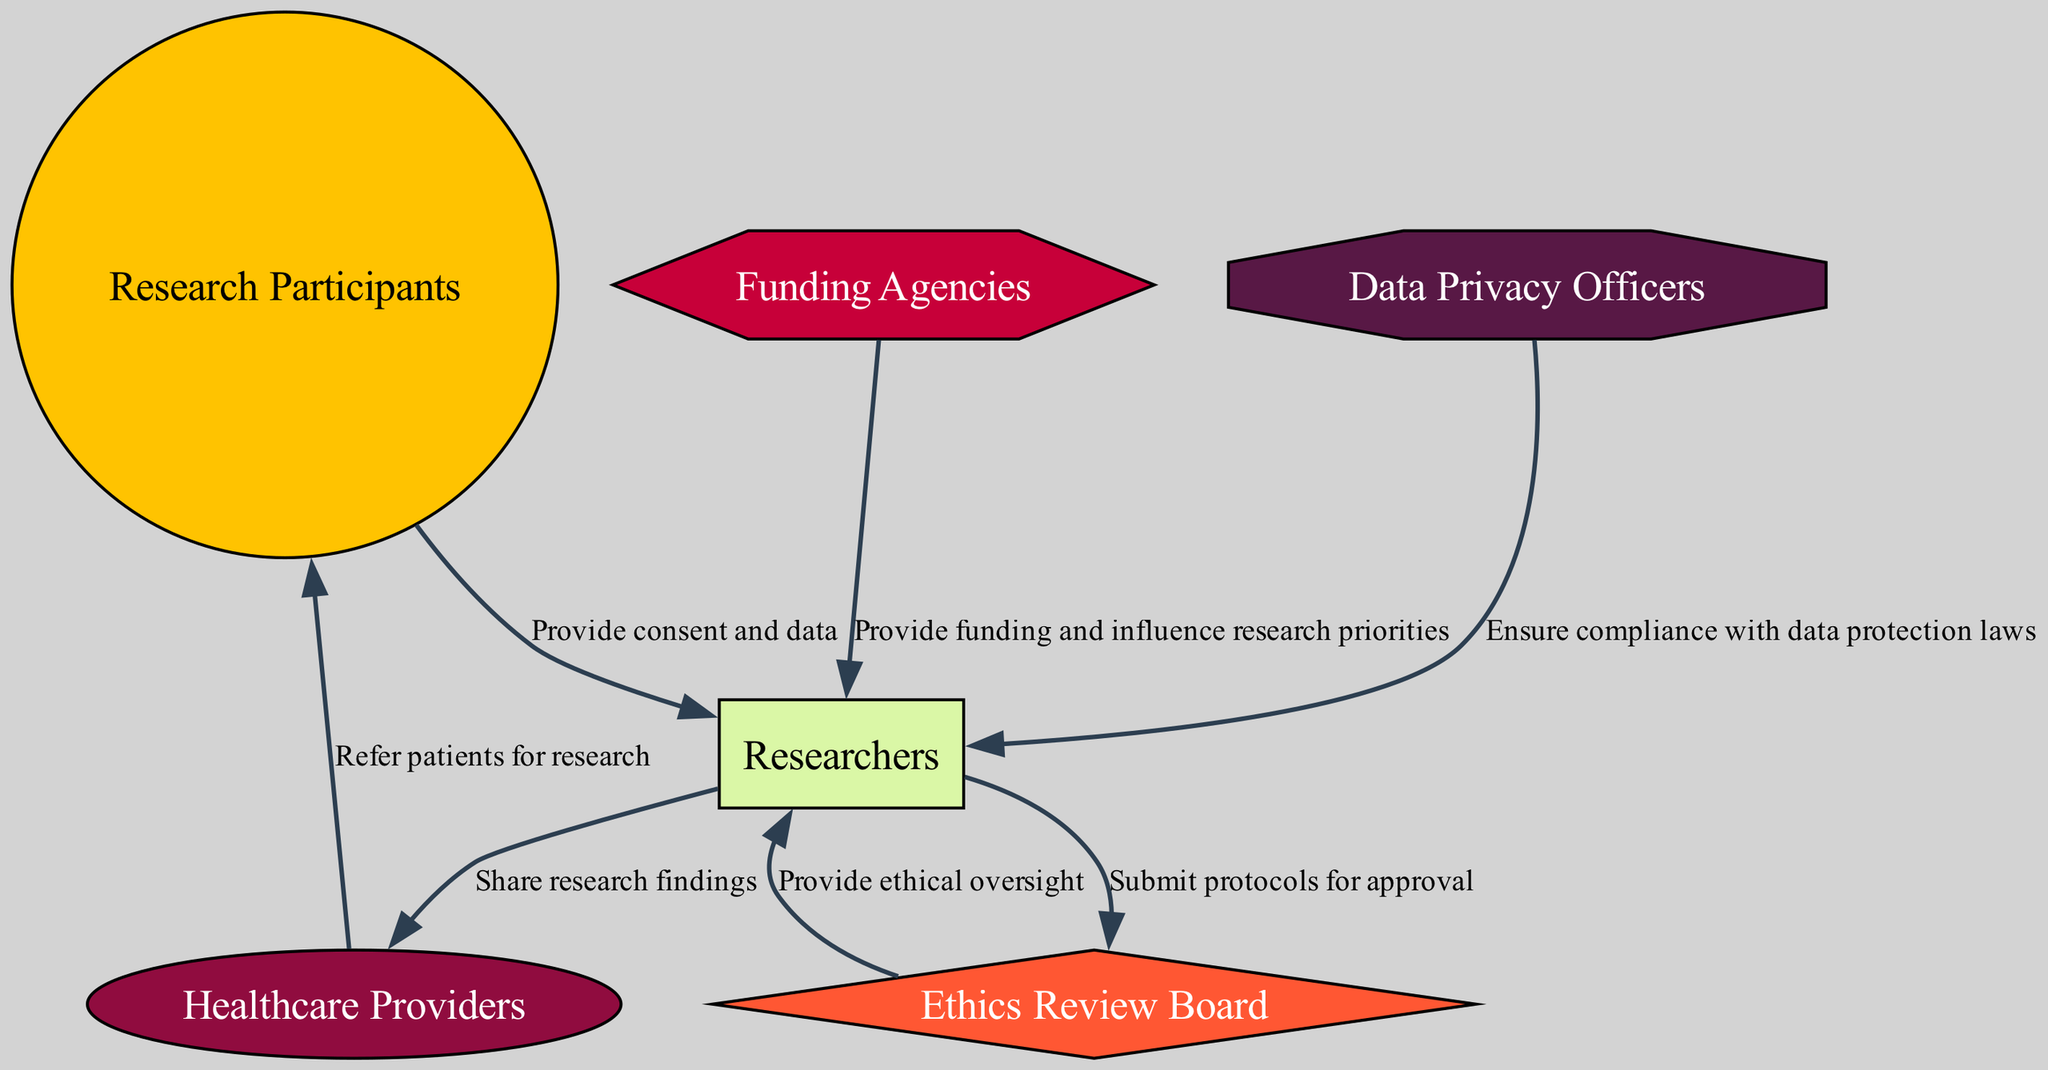What is the total number of nodes in the diagram? The diagram contains six entities: Research Participants, Researchers, Ethics Review Board, Funding Agencies, Healthcare Providers, and Data Privacy Officers. These entities are counted to arrive at a total of six.
Answer: 6 What relationship does the Ethics Review Board have with Researchers? The Ethics Review Board provides ethical oversight to the Researchers, which indicates a supervisory and evaluative relationship, ensuring that research practices align with ethical standards.
Answer: Provide ethical oversight Who submits protocols for approval? The Researchers are responsible for submitting their research protocols to the Ethics Review Board for approval, demonstrating a responsible process for establishing adherence to ethical guidelines before conducting studies.
Answer: Researchers What is the role of Data Privacy Officers? Data Privacy Officers are tasked with ensuring compliance with data protection laws, which is crucial for maintaining the integrity and confidentiality of the medical imaging data involved in research activities.
Answer: Ensure compliance with data protection laws Which stakeholders provide financial support to Researchers? Funding Agencies are the stakeholders that provide financial support to Researchers, necessary for funding the medical imaging studies and influencing the priorities of the research conducted.
Answer: Funding Agencies Why is it important for Healthcare Providers to refer patients for research? Healthcare Providers play a vital role in referring patients for research as they serve as a bridge between patient care and research opportunities, ensuring that potential participants receive the opportunity to contribute to advancements in medical imaging studies.
Answer: It connects patient care and research opportunities What flow of influence can be traced from Funding Agencies to Researchers? Funding Agencies provide funding and influence research priorities, which means that they not only support the financial aspect but also can guide the direction of research projects undertaken by Researchers based on their funding priorities.
Answer: Influence research priorities How does the relationship between Researchers and Research Participants begin? The relationship initiates with Research Participants providing consent and data to Researchers, hence establishing a foundational basis for any further interaction or research activity involving imaging data.
Answer: Provide consent and data What action is shared between Researchers and Healthcare Providers? Researchers share research findings with Healthcare Providers, which facilitates the integration of new knowledge and discoveries into clinical practice, thereby enhancing the overall healthcare ecosystem.
Answer: Share research findings 